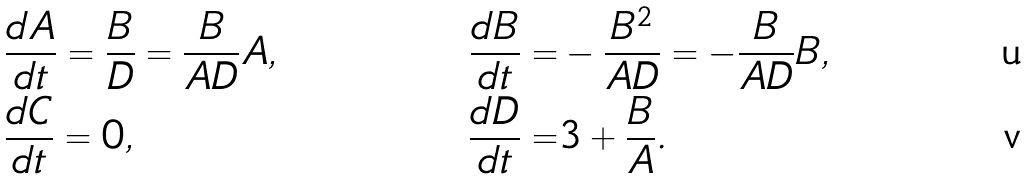Convert formula to latex. <formula><loc_0><loc_0><loc_500><loc_500>& \frac { d A } { d t } = \frac { B } { D } = \frac { B } { A D } A , & \frac { d B } { d t } = & - \frac { B ^ { 2 } } { A D } = - \frac { B } { A D } B , \\ & \frac { d C } { d t } = 0 , & \frac { d D } { d t } = & 3 + \frac { B } { A } .</formula> 